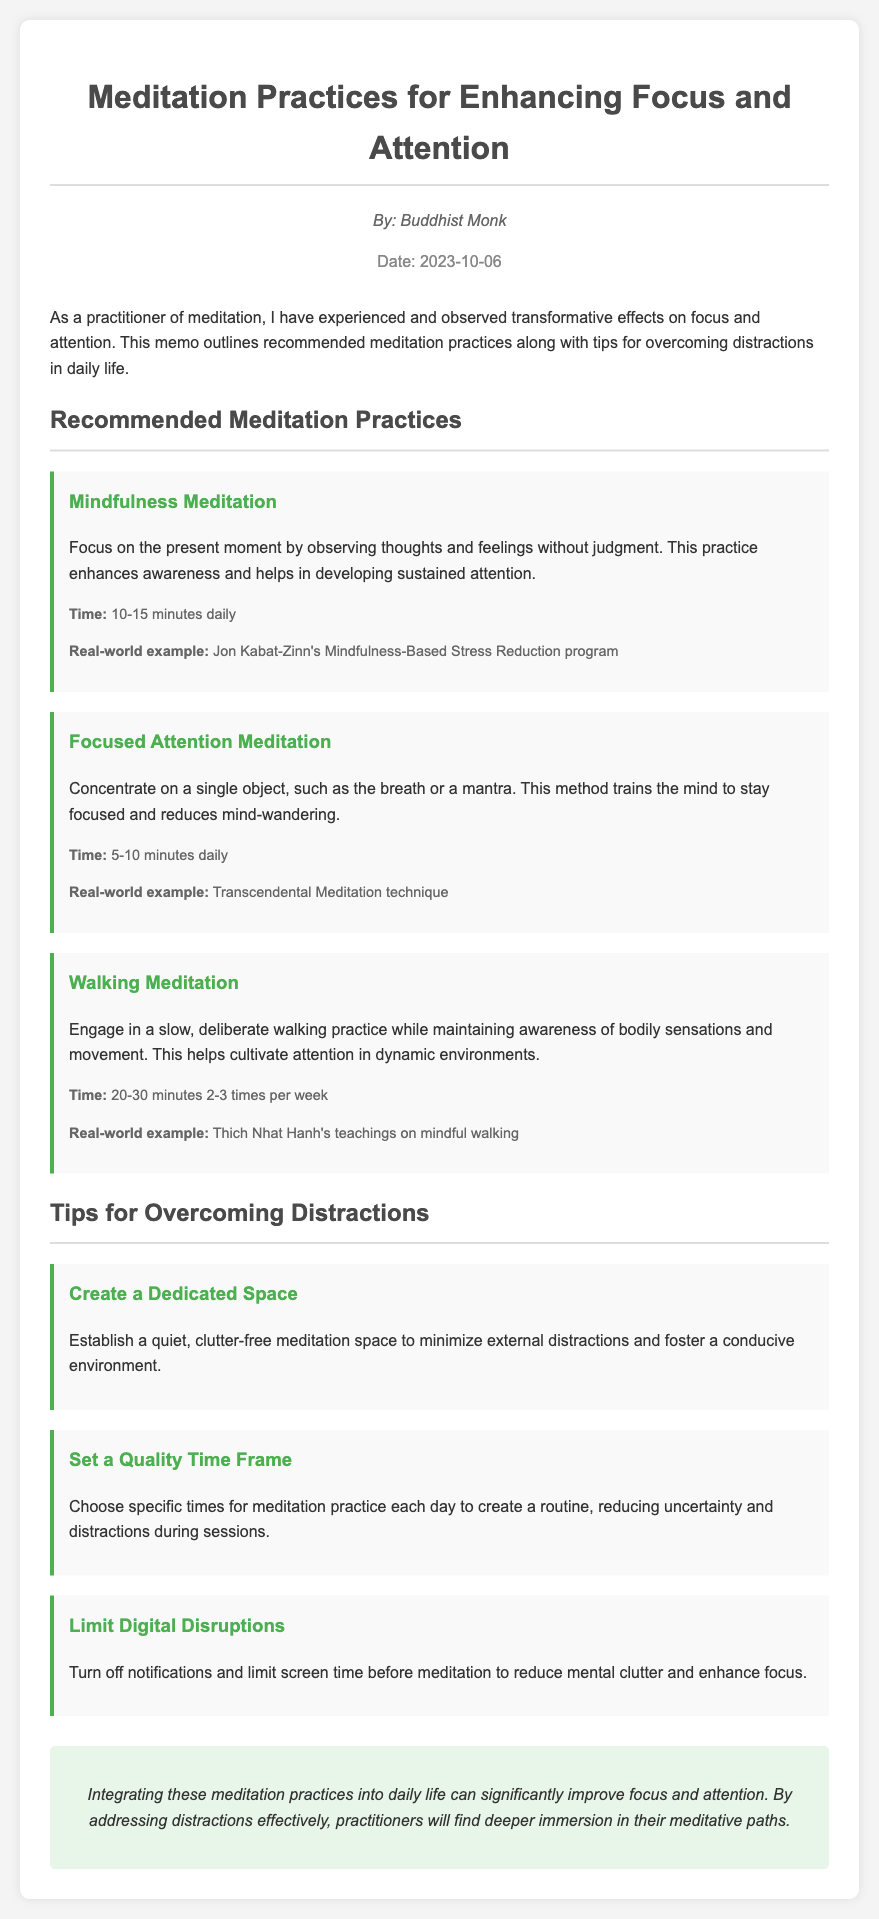What is the title of the memo? The title is given in the header of the document, stating the main topic of discussion.
Answer: Meditation Practices for Enhancing Focus and Attention Who is the author of the memo? The author is specified below the title, indicating the individual who compiled the information.
Answer: Buddhist Monk What is the date of the memo? The date is provided in the header, indicating when the memo was created.
Answer: 2023-10-06 How long should Mindfulness Meditation be practiced daily? The memo states the recommended duration for this specific meditation practice.
Answer: 10-15 minutes daily What is one tip for overcoming distractions? The memo lists multiple tips aimed at improving focus, one of which can be selected.
Answer: Create a Dedicated Space What type of meditation involves concentrating on a single object? The document includes specific types of meditation practices and highlights this particular approach.
Answer: Focused Attention Meditation How often should Walking Meditation be practiced? The frequency of this meditation type is indicated in the recommendation section.
Answer: 2-3 times per week What is the real-world example for Walking Meditation? The memo provides a practical illustration to support the meditation type described.
Answer: Thich Nhat Hanh's teachings on mindful walking What is advised to limit before meditation? The tips provided suggest certain actions to enhance meditation effectiveness.
Answer: Digital Disruptions 